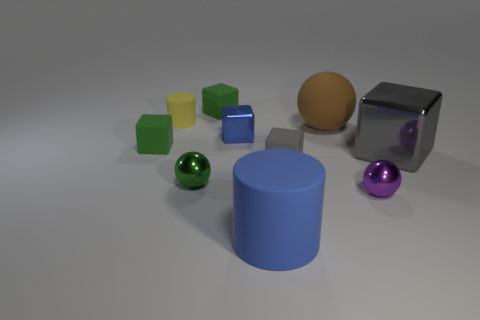Subtract all blue blocks. How many blocks are left? 4 Subtract all tiny metal blocks. How many blocks are left? 4 Subtract all brown blocks. Subtract all cyan cylinders. How many blocks are left? 5 Subtract all cylinders. How many objects are left? 8 Add 2 large brown spheres. How many large brown spheres exist? 3 Subtract 1 green balls. How many objects are left? 9 Subtract all small green spheres. Subtract all big matte things. How many objects are left? 7 Add 9 small blue metal cubes. How many small blue metal cubes are left? 10 